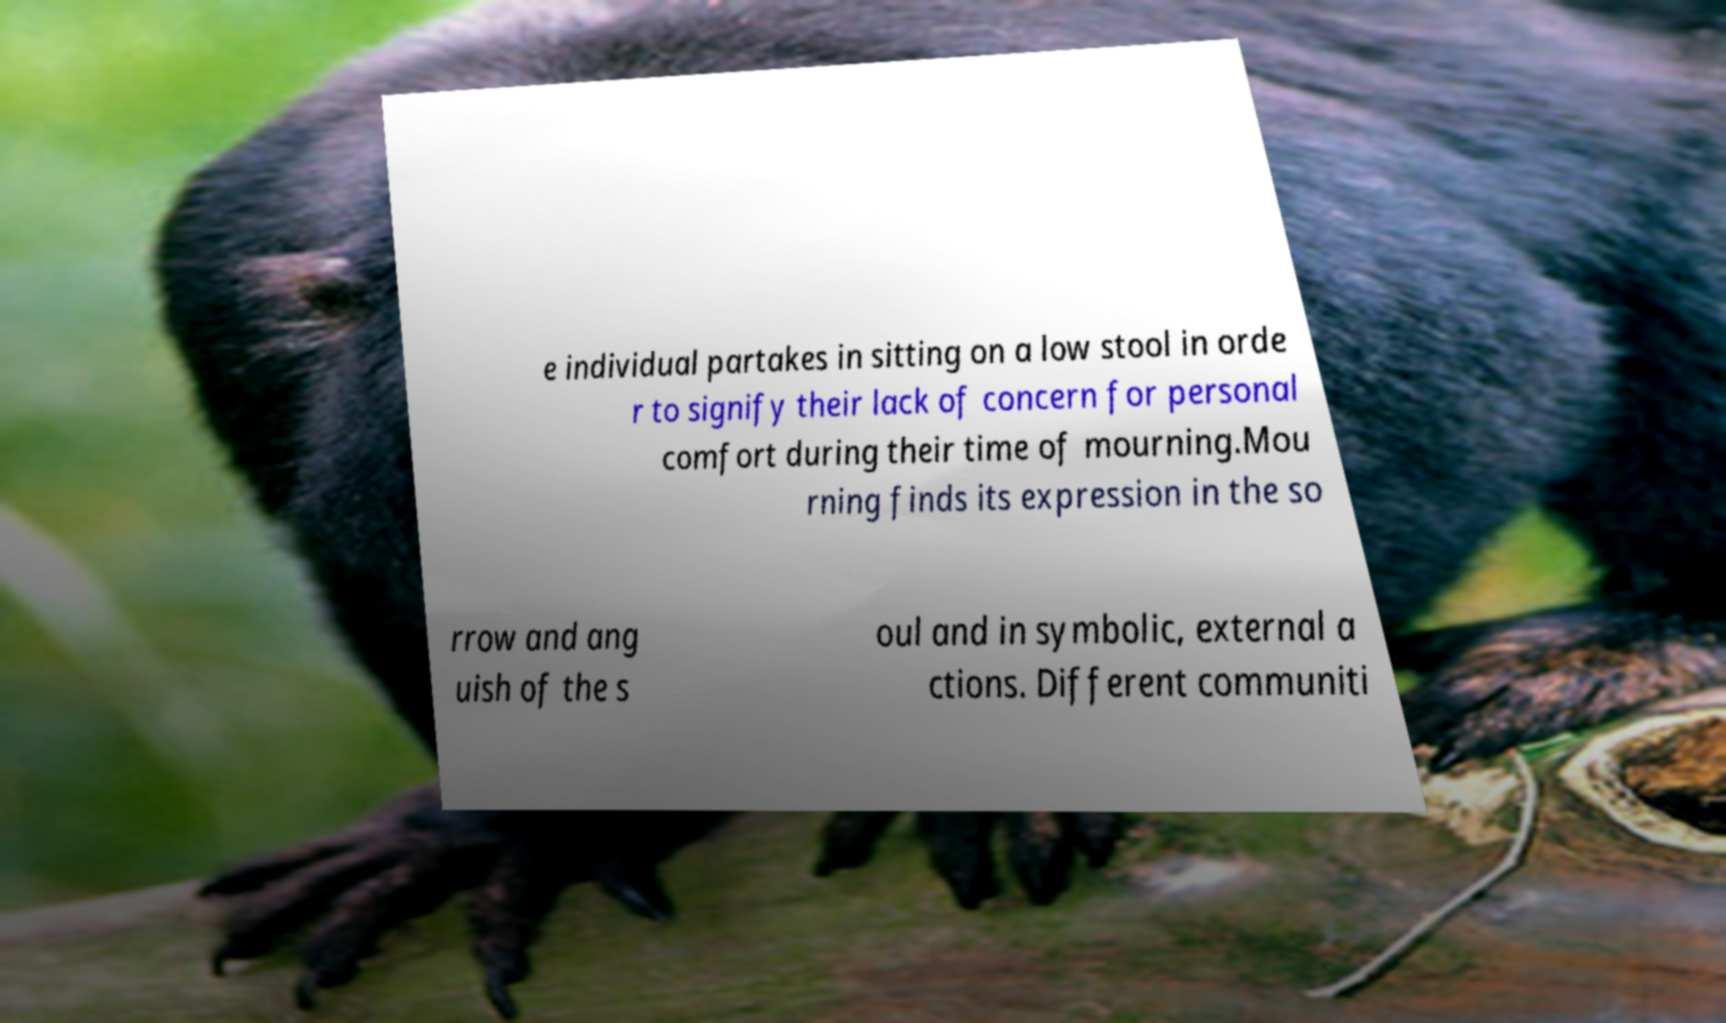Could you extract and type out the text from this image? e individual partakes in sitting on a low stool in orde r to signify their lack of concern for personal comfort during their time of mourning.Mou rning finds its expression in the so rrow and ang uish of the s oul and in symbolic, external a ctions. Different communiti 